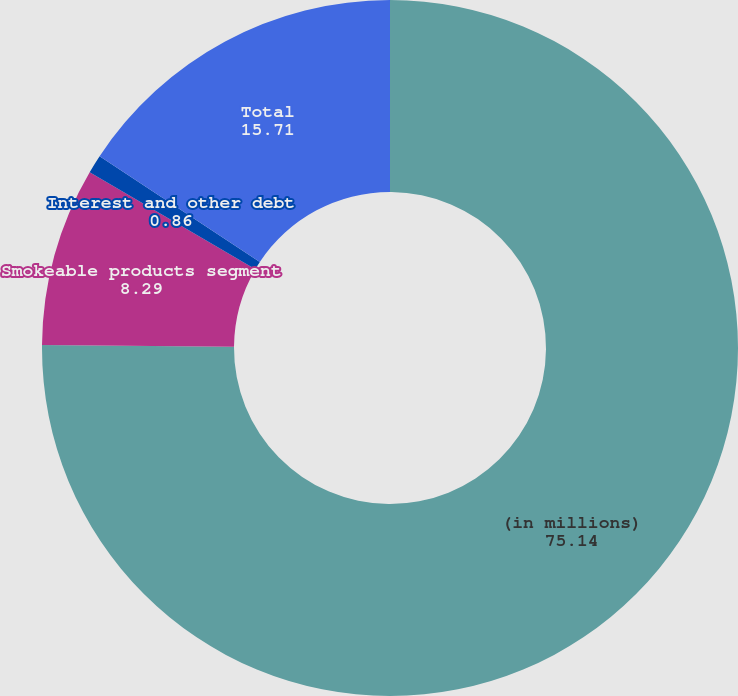Convert chart. <chart><loc_0><loc_0><loc_500><loc_500><pie_chart><fcel>(in millions)<fcel>Smokeable products segment<fcel>Interest and other debt<fcel>Total<nl><fcel>75.14%<fcel>8.29%<fcel>0.86%<fcel>15.71%<nl></chart> 